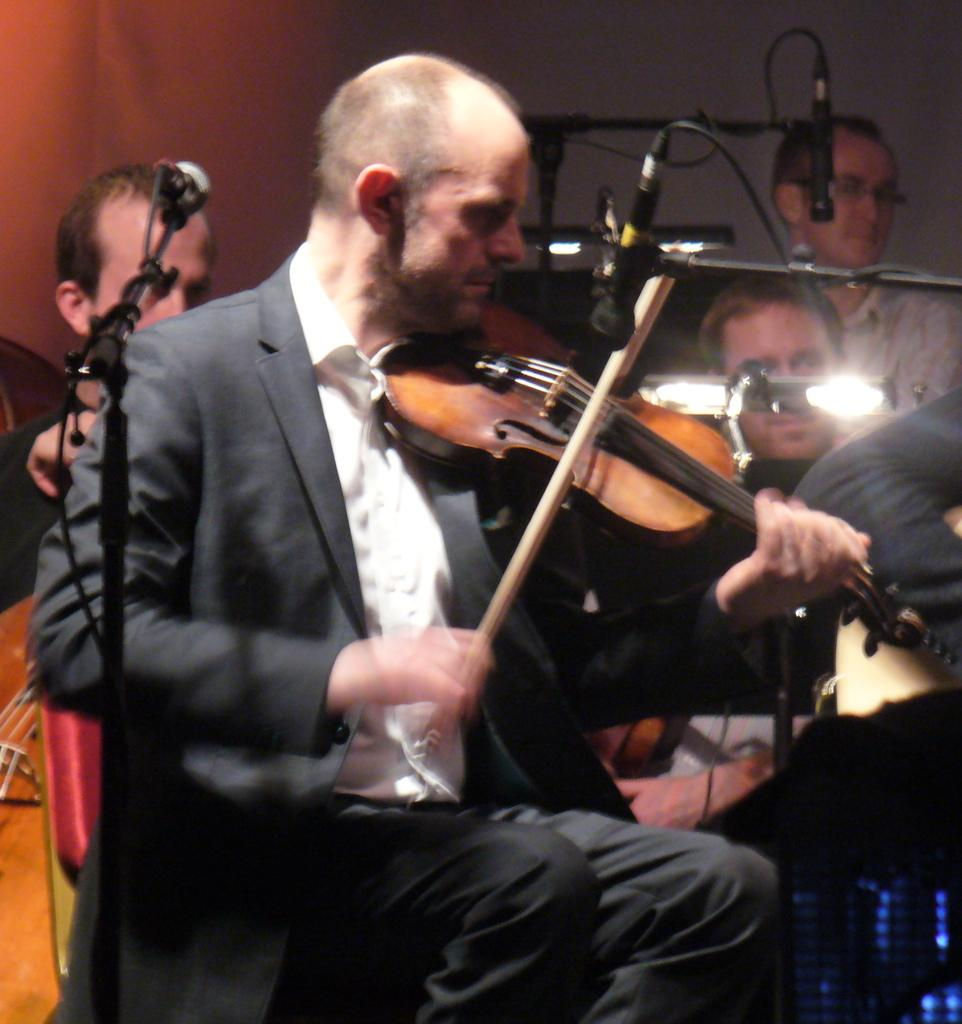What is the man in the image doing? The man is sitting on a chair and holding a guitar in his hands. What object is associated with the man's activity? There is a microphone in the image. Can you describe the people in the background? There are two people in the background, one of whom is a man on the left side. What type of planes can be seen flying in the image? There are no planes visible in the image. 